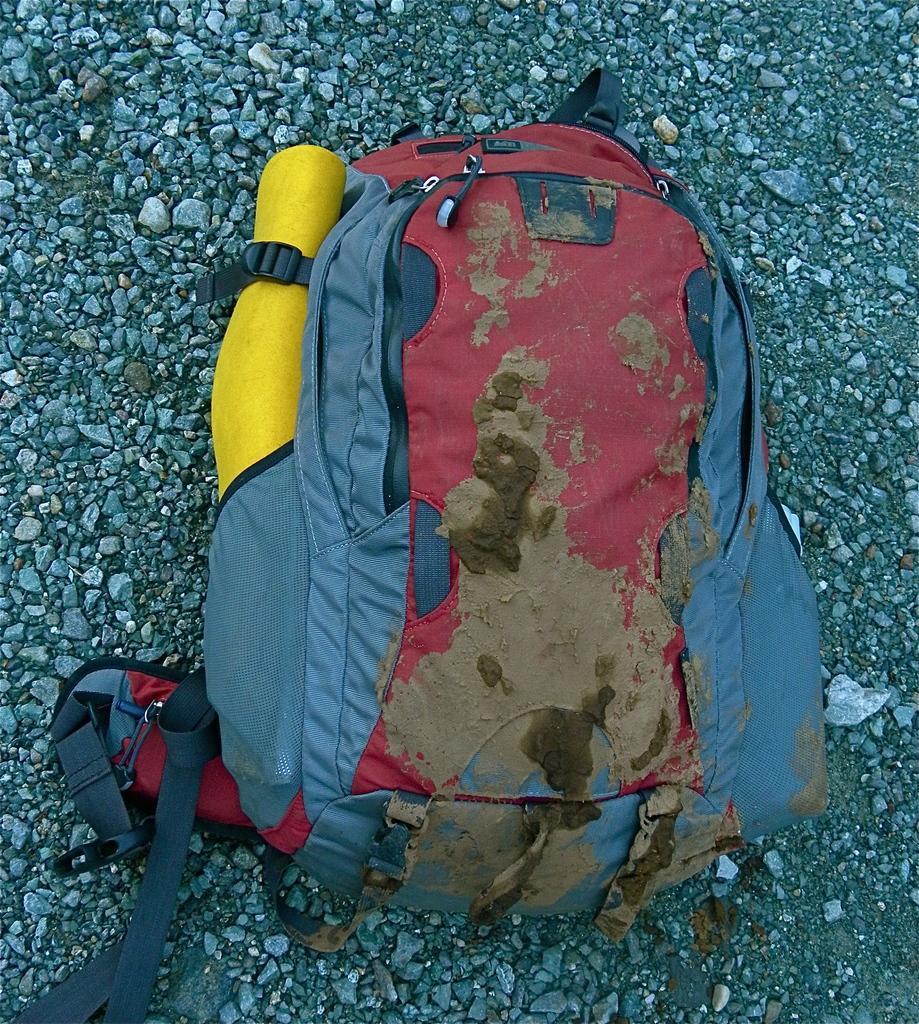Can you describe this image briefly? In this image i can see a back pack of gray color and kept on the floor and there are some stones on the floor 